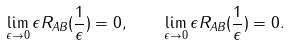<formula> <loc_0><loc_0><loc_500><loc_500>\lim _ { \epsilon \rightarrow 0 } \epsilon R _ { A B } ( \frac { 1 } { \epsilon } ) = 0 , \quad \lim _ { \epsilon \rightarrow 0 } \epsilon R _ { A B } ( \frac { 1 } { \epsilon } ) = 0 .</formula> 